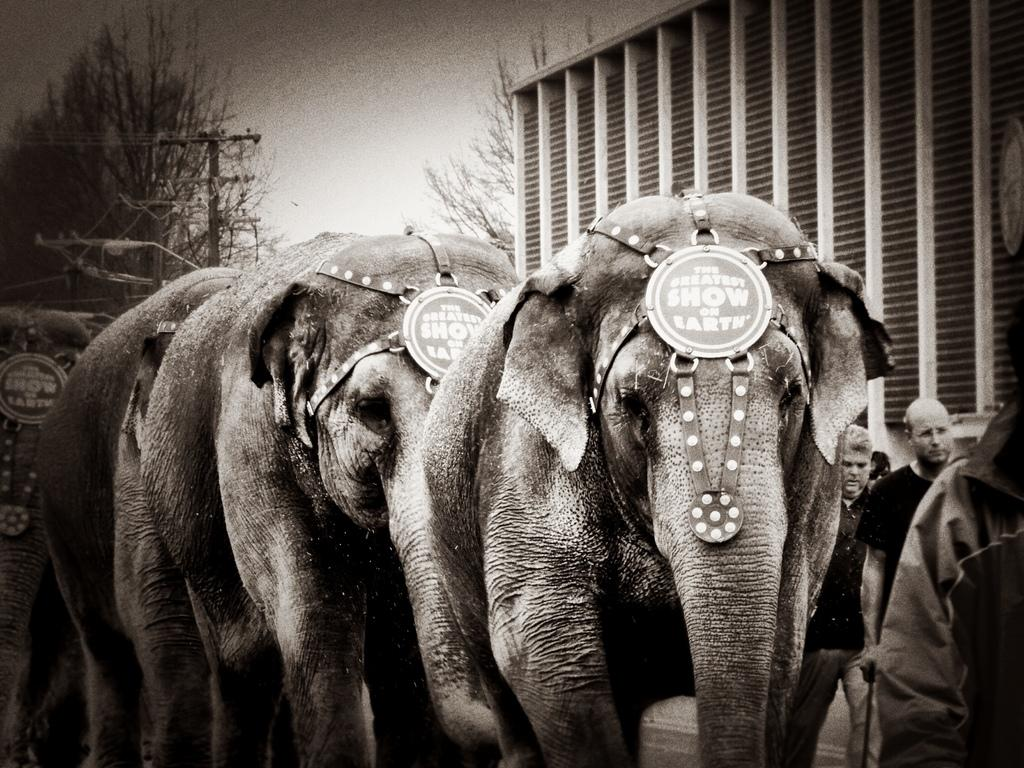What is the color scheme of the image? The image is black and white. What animals are present in the image? There are elephants in the image. Are there any human figures in the image? Yes, there are people in the image. What structures can be seen in the background of the image? There is a street light, an electric pole, wires, trees, and a building in the background. What type of linen is being used as a backdrop in the image? There is no linen present in the image; it is a black and white photograph featuring elephants, people, and various background elements. Can you provide an example of a similar scene in a different location? The provided image is the only scene available, and we cannot provide an example of a similar scene in a different location based on the information given. 